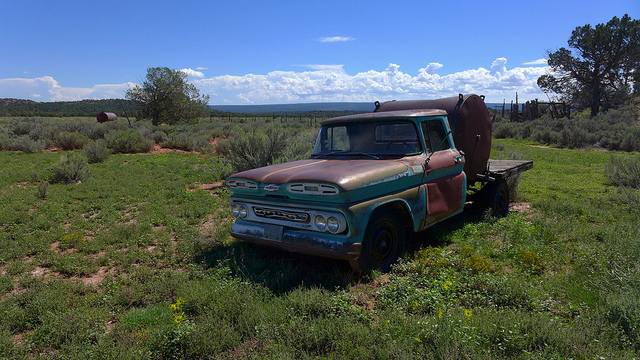Has the older truck been well maintained mechanically? From the image alone, it's difficult to accurately assess the mechanical maintenance of the older truck without additional information or inspection records. Visual clues like the presence of rust, the condition of tires, and any visible damage can provide superficial hints but are not definitive indicators of the truck's mechanical health. For a precise evaluation, a professional inspection would be necessary. 